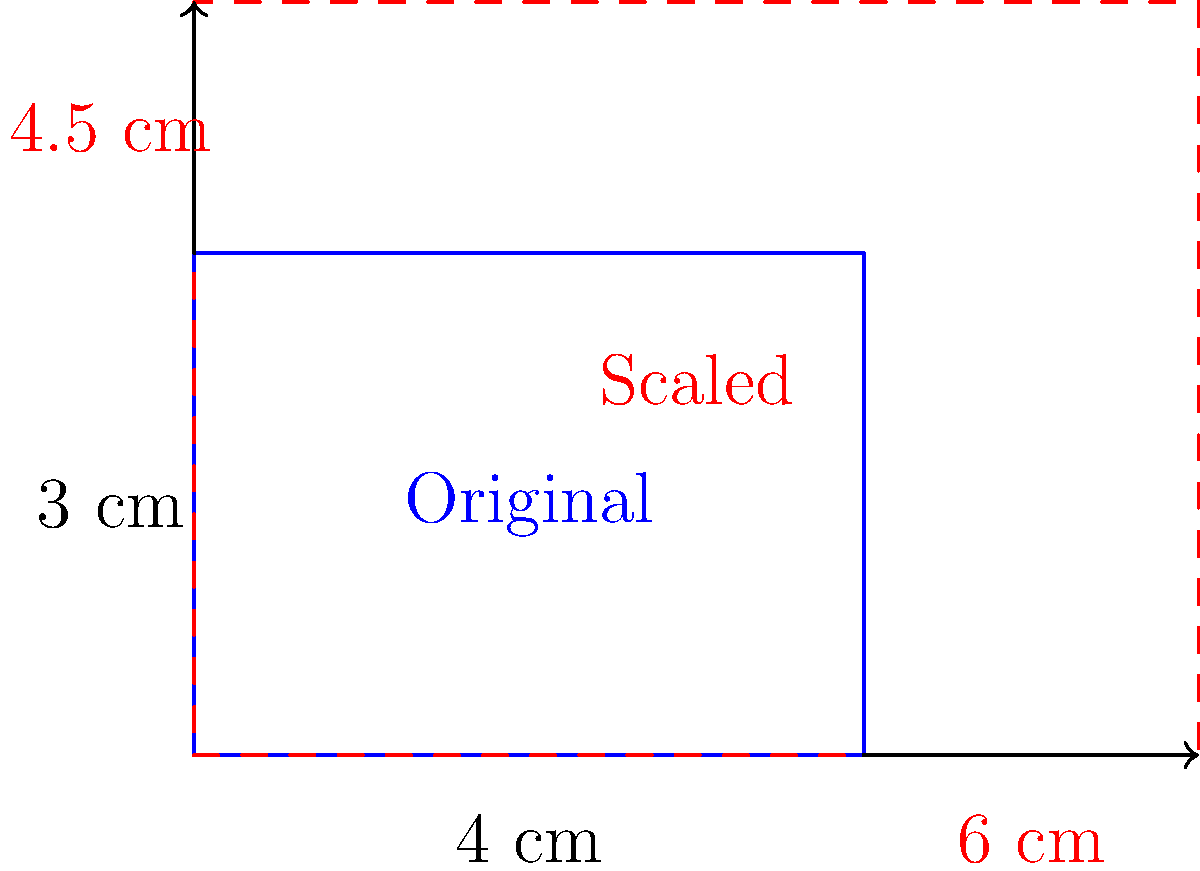Your grandchild's eSports team has won a championship, and you want to surprise them by creating a larger version of their trophy for display. The original trophy design is a rectangular prism with a base of 4 cm by 3 cm. If you want to scale up the trophy so that the new base is 6 cm by 4.5 cm, what scale factor should you use? To find the scale factor, we need to compare the new dimensions to the original dimensions:

1. For the width:
   New width = 6 cm
   Original width = 4 cm
   Scale factor for width = $\frac{6}{4} = 1.5$

2. For the height:
   New height = 4.5 cm
   Original height = 3 cm
   Scale factor for height = $\frac{4.5}{3} = 1.5$

We can see that both the width and height have been scaled by the same factor of 1.5. This is important because we want to maintain the proportions of the original trophy.

To verify:
$4 \times 1.5 = 6$ cm (new width)
$3 \times 1.5 = 4.5$ cm (new height)

Therefore, the scale factor to use for creating the larger version of the trophy is 1.5.
Answer: 1.5 